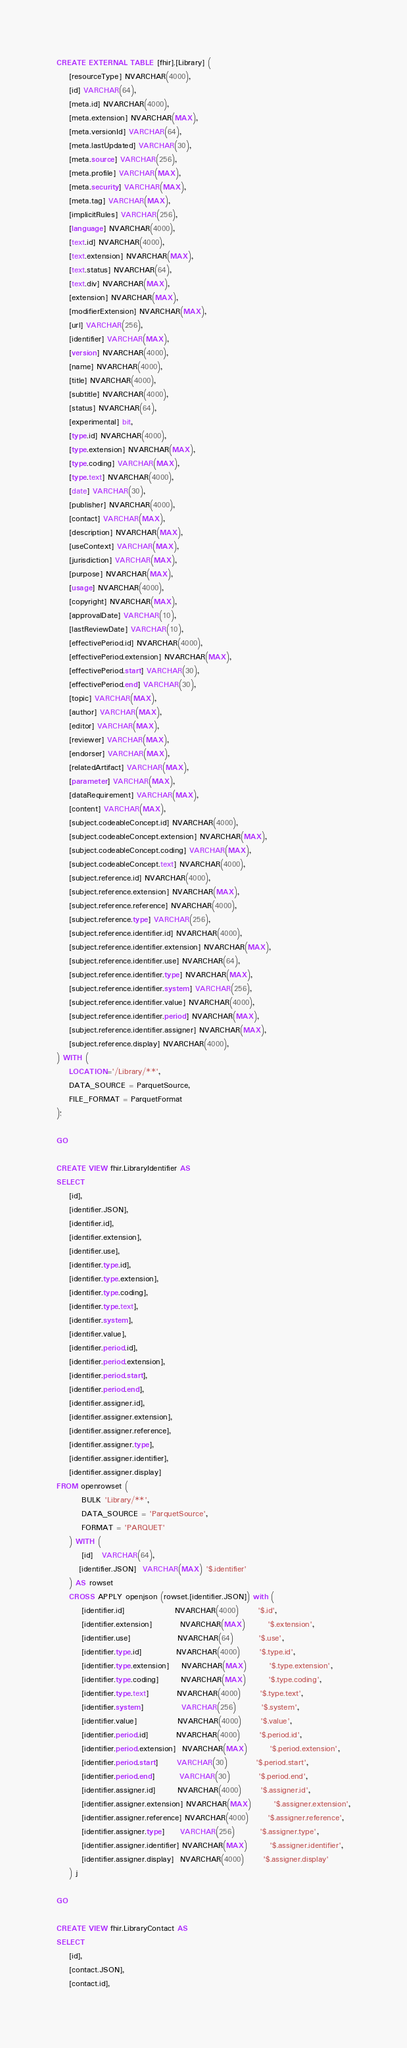Convert code to text. <code><loc_0><loc_0><loc_500><loc_500><_SQL_>CREATE EXTERNAL TABLE [fhir].[Library] (
    [resourceType] NVARCHAR(4000),
    [id] VARCHAR(64),
    [meta.id] NVARCHAR(4000),
    [meta.extension] NVARCHAR(MAX),
    [meta.versionId] VARCHAR(64),
    [meta.lastUpdated] VARCHAR(30),
    [meta.source] VARCHAR(256),
    [meta.profile] VARCHAR(MAX),
    [meta.security] VARCHAR(MAX),
    [meta.tag] VARCHAR(MAX),
    [implicitRules] VARCHAR(256),
    [language] NVARCHAR(4000),
    [text.id] NVARCHAR(4000),
    [text.extension] NVARCHAR(MAX),
    [text.status] NVARCHAR(64),
    [text.div] NVARCHAR(MAX),
    [extension] NVARCHAR(MAX),
    [modifierExtension] NVARCHAR(MAX),
    [url] VARCHAR(256),
    [identifier] VARCHAR(MAX),
    [version] NVARCHAR(4000),
    [name] NVARCHAR(4000),
    [title] NVARCHAR(4000),
    [subtitle] NVARCHAR(4000),
    [status] NVARCHAR(64),
    [experimental] bit,
    [type.id] NVARCHAR(4000),
    [type.extension] NVARCHAR(MAX),
    [type.coding] VARCHAR(MAX),
    [type.text] NVARCHAR(4000),
    [date] VARCHAR(30),
    [publisher] NVARCHAR(4000),
    [contact] VARCHAR(MAX),
    [description] NVARCHAR(MAX),
    [useContext] VARCHAR(MAX),
    [jurisdiction] VARCHAR(MAX),
    [purpose] NVARCHAR(MAX),
    [usage] NVARCHAR(4000),
    [copyright] NVARCHAR(MAX),
    [approvalDate] VARCHAR(10),
    [lastReviewDate] VARCHAR(10),
    [effectivePeriod.id] NVARCHAR(4000),
    [effectivePeriod.extension] NVARCHAR(MAX),
    [effectivePeriod.start] VARCHAR(30),
    [effectivePeriod.end] VARCHAR(30),
    [topic] VARCHAR(MAX),
    [author] VARCHAR(MAX),
    [editor] VARCHAR(MAX),
    [reviewer] VARCHAR(MAX),
    [endorser] VARCHAR(MAX),
    [relatedArtifact] VARCHAR(MAX),
    [parameter] VARCHAR(MAX),
    [dataRequirement] VARCHAR(MAX),
    [content] VARCHAR(MAX),
    [subject.codeableConcept.id] NVARCHAR(4000),
    [subject.codeableConcept.extension] NVARCHAR(MAX),
    [subject.codeableConcept.coding] VARCHAR(MAX),
    [subject.codeableConcept.text] NVARCHAR(4000),
    [subject.reference.id] NVARCHAR(4000),
    [subject.reference.extension] NVARCHAR(MAX),
    [subject.reference.reference] NVARCHAR(4000),
    [subject.reference.type] VARCHAR(256),
    [subject.reference.identifier.id] NVARCHAR(4000),
    [subject.reference.identifier.extension] NVARCHAR(MAX),
    [subject.reference.identifier.use] NVARCHAR(64),
    [subject.reference.identifier.type] NVARCHAR(MAX),
    [subject.reference.identifier.system] VARCHAR(256),
    [subject.reference.identifier.value] NVARCHAR(4000),
    [subject.reference.identifier.period] NVARCHAR(MAX),
    [subject.reference.identifier.assigner] NVARCHAR(MAX),
    [subject.reference.display] NVARCHAR(4000),
) WITH (
    LOCATION='/Library/**',
    DATA_SOURCE = ParquetSource,
    FILE_FORMAT = ParquetFormat
);

GO

CREATE VIEW fhir.LibraryIdentifier AS
SELECT
    [id],
    [identifier.JSON],
    [identifier.id],
    [identifier.extension],
    [identifier.use],
    [identifier.type.id],
    [identifier.type.extension],
    [identifier.type.coding],
    [identifier.type.text],
    [identifier.system],
    [identifier.value],
    [identifier.period.id],
    [identifier.period.extension],
    [identifier.period.start],
    [identifier.period.end],
    [identifier.assigner.id],
    [identifier.assigner.extension],
    [identifier.assigner.reference],
    [identifier.assigner.type],
    [identifier.assigner.identifier],
    [identifier.assigner.display]
FROM openrowset (
        BULK 'Library/**',
        DATA_SOURCE = 'ParquetSource',
        FORMAT = 'PARQUET'
    ) WITH (
        [id]   VARCHAR(64),
       [identifier.JSON]  VARCHAR(MAX) '$.identifier'
    ) AS rowset
    CROSS APPLY openjson (rowset.[identifier.JSON]) with (
        [identifier.id]                NVARCHAR(4000)      '$.id',
        [identifier.extension]         NVARCHAR(MAX)       '$.extension',
        [identifier.use]               NVARCHAR(64)        '$.use',
        [identifier.type.id]           NVARCHAR(4000)      '$.type.id',
        [identifier.type.extension]    NVARCHAR(MAX)       '$.type.extension',
        [identifier.type.coding]       NVARCHAR(MAX)       '$.type.coding',
        [identifier.type.text]         NVARCHAR(4000)      '$.type.text',
        [identifier.system]            VARCHAR(256)        '$.system',
        [identifier.value]             NVARCHAR(4000)      '$.value',
        [identifier.period.id]         NVARCHAR(4000)      '$.period.id',
        [identifier.period.extension]  NVARCHAR(MAX)       '$.period.extension',
        [identifier.period.start]      VARCHAR(30)         '$.period.start',
        [identifier.period.end]        VARCHAR(30)         '$.period.end',
        [identifier.assigner.id]       NVARCHAR(4000)      '$.assigner.id',
        [identifier.assigner.extension] NVARCHAR(MAX)       '$.assigner.extension',
        [identifier.assigner.reference] NVARCHAR(4000)      '$.assigner.reference',
        [identifier.assigner.type]     VARCHAR(256)        '$.assigner.type',
        [identifier.assigner.identifier] NVARCHAR(MAX)       '$.assigner.identifier',
        [identifier.assigner.display]  NVARCHAR(4000)      '$.assigner.display'
    ) j

GO

CREATE VIEW fhir.LibraryContact AS
SELECT
    [id],
    [contact.JSON],
    [contact.id],</code> 